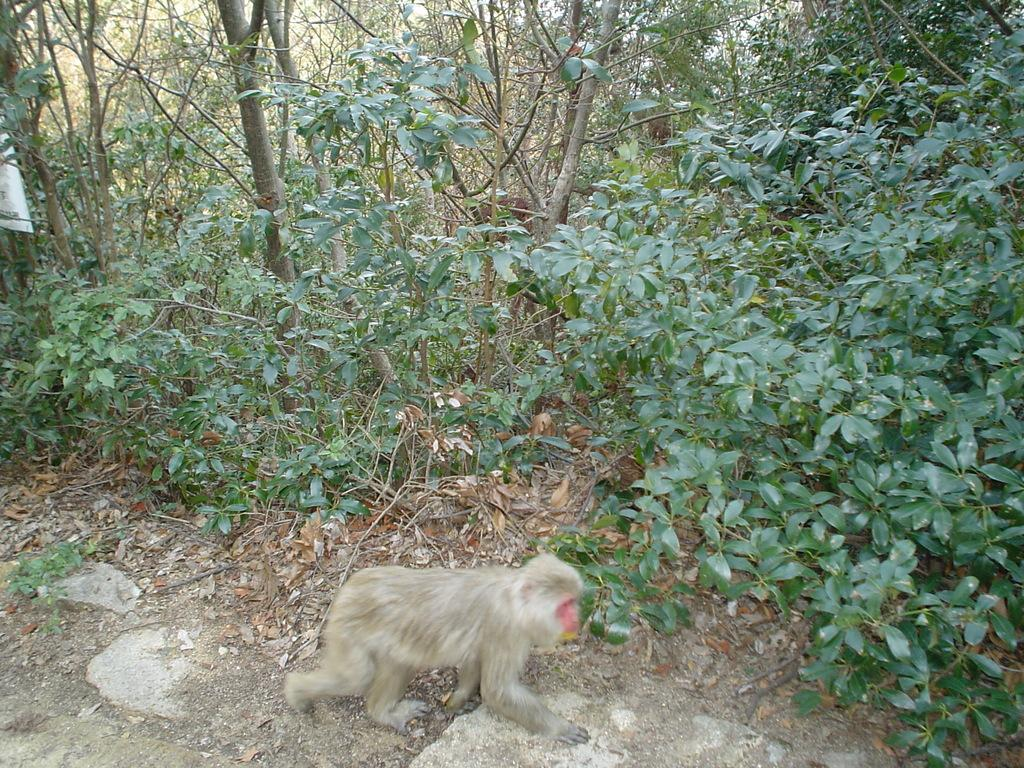What type of animal is present in the image? There is a monkey in the image. What other natural elements can be seen in the image? There are plants and trees visible in the image. Can you tell me how many people are visible in the image? There are no people present in the image; it features a monkey, plants, and trees. What type of hose can be seen in the image? There is no hose present in the image. 